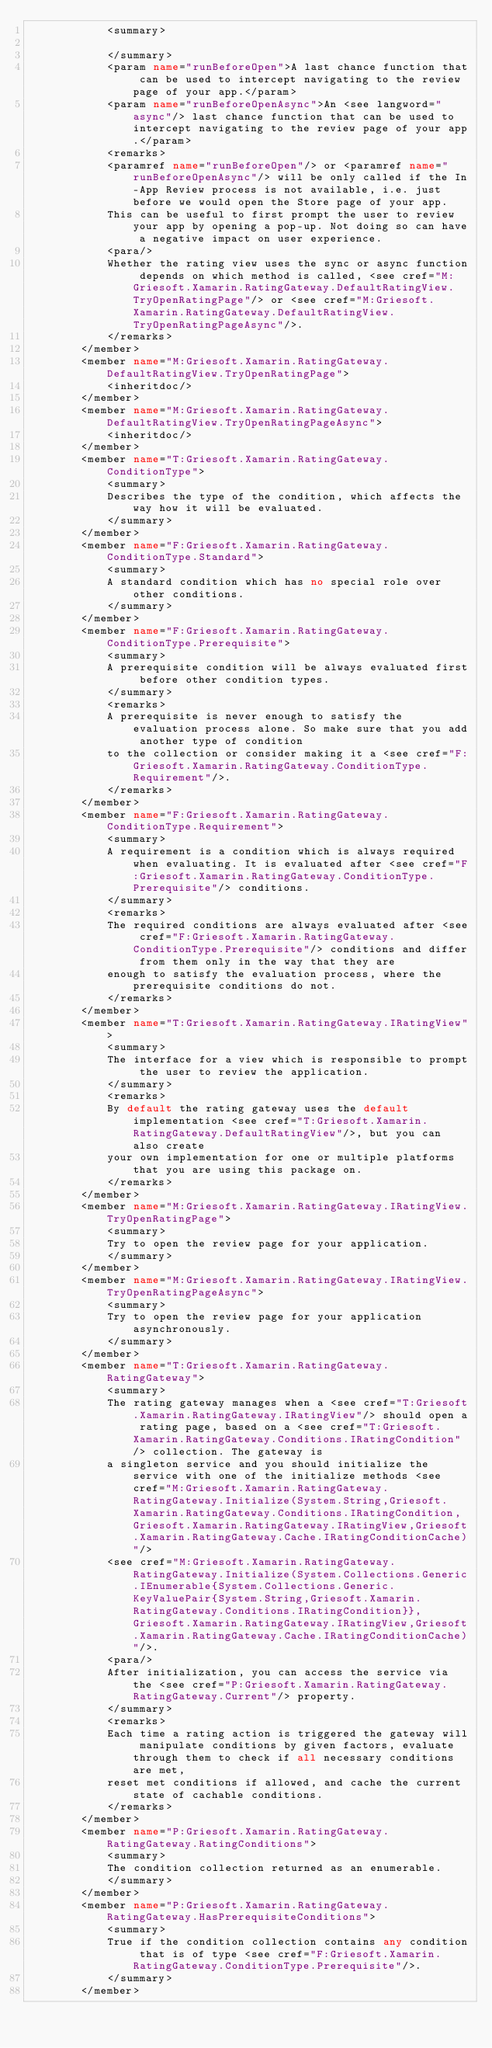<code> <loc_0><loc_0><loc_500><loc_500><_XML_>            <summary>
            
            </summary>
            <param name="runBeforeOpen">A last chance function that can be used to intercept navigating to the review page of your app.</param>
            <param name="runBeforeOpenAsync">An <see langword="async"/> last chance function that can be used to intercept navigating to the review page of your app.</param>
            <remarks>
            <paramref name="runBeforeOpen"/> or <paramref name="runBeforeOpenAsync"/> will be only called if the In-App Review process is not available, i.e. just before we would open the Store page of your app.
            This can be useful to first prompt the user to review your app by opening a pop-up. Not doing so can have a negative impact on user experience.
            <para/>
            Whether the rating view uses the sync or async function depends on which method is called, <see cref="M:Griesoft.Xamarin.RatingGateway.DefaultRatingView.TryOpenRatingPage"/> or <see cref="M:Griesoft.Xamarin.RatingGateway.DefaultRatingView.TryOpenRatingPageAsync"/>.
            </remarks>
        </member>
        <member name="M:Griesoft.Xamarin.RatingGateway.DefaultRatingView.TryOpenRatingPage">
            <inheritdoc/>
        </member>
        <member name="M:Griesoft.Xamarin.RatingGateway.DefaultRatingView.TryOpenRatingPageAsync">
            <inheritdoc/>
        </member>
        <member name="T:Griesoft.Xamarin.RatingGateway.ConditionType">
            <summary>
            Describes the type of the condition, which affects the way how it will be evaluated.
            </summary>
        </member>
        <member name="F:Griesoft.Xamarin.RatingGateway.ConditionType.Standard">
            <summary>
            A standard condition which has no special role over other conditions.
            </summary>
        </member>
        <member name="F:Griesoft.Xamarin.RatingGateway.ConditionType.Prerequisite">
            <summary>
            A prerequisite condition will be always evaluated first before other condition types.
            </summary>
            <remarks>
            A prerequisite is never enough to satisfy the evaluation process alone. So make sure that you add another type of condition
            to the collection or consider making it a <see cref="F:Griesoft.Xamarin.RatingGateway.ConditionType.Requirement"/>.
            </remarks>
        </member>
        <member name="F:Griesoft.Xamarin.RatingGateway.ConditionType.Requirement">
            <summary>
            A requirement is a condition which is always required when evaluating. It is evaluated after <see cref="F:Griesoft.Xamarin.RatingGateway.ConditionType.Prerequisite"/> conditions.
            </summary>
            <remarks>
            The required conditions are always evaluated after <see cref="F:Griesoft.Xamarin.RatingGateway.ConditionType.Prerequisite"/> conditions and differ from them only in the way that they are
            enough to satisfy the evaluation process, where the prerequisite conditions do not.
            </remarks>
        </member>
        <member name="T:Griesoft.Xamarin.RatingGateway.IRatingView">
            <summary>
            The interface for a view which is responsible to prompt the user to review the application.
            </summary>
            <remarks>
            By default the rating gateway uses the default implementation <see cref="T:Griesoft.Xamarin.RatingGateway.DefaultRatingView"/>, but you can also create
            your own implementation for one or multiple platforms that you are using this package on.
            </remarks>
        </member>
        <member name="M:Griesoft.Xamarin.RatingGateway.IRatingView.TryOpenRatingPage">
            <summary>
            Try to open the review page for your application.
            </summary>
        </member>
        <member name="M:Griesoft.Xamarin.RatingGateway.IRatingView.TryOpenRatingPageAsync">
            <summary>
            Try to open the review page for your application asynchronously.
            </summary>
        </member>
        <member name="T:Griesoft.Xamarin.RatingGateway.RatingGateway">
            <summary>
            The rating gateway manages when a <see cref="T:Griesoft.Xamarin.RatingGateway.IRatingView"/> should open a rating page, based on a <see cref="T:Griesoft.Xamarin.RatingGateway.Conditions.IRatingCondition"/> collection. The gateway is
            a singleton service and you should initialize the service with one of the initialize methods <see cref="M:Griesoft.Xamarin.RatingGateway.RatingGateway.Initialize(System.String,Griesoft.Xamarin.RatingGateway.Conditions.IRatingCondition,Griesoft.Xamarin.RatingGateway.IRatingView,Griesoft.Xamarin.RatingGateway.Cache.IRatingConditionCache)"/>
            <see cref="M:Griesoft.Xamarin.RatingGateway.RatingGateway.Initialize(System.Collections.Generic.IEnumerable{System.Collections.Generic.KeyValuePair{System.String,Griesoft.Xamarin.RatingGateway.Conditions.IRatingCondition}},Griesoft.Xamarin.RatingGateway.IRatingView,Griesoft.Xamarin.RatingGateway.Cache.IRatingConditionCache)"/>.
            <para/>
            After initialization, you can access the service via the <see cref="P:Griesoft.Xamarin.RatingGateway.RatingGateway.Current"/> property.
            </summary>
            <remarks>
            Each time a rating action is triggered the gateway will manipulate conditions by given factors, evaluate through them to check if all necessary conditions are met,
            reset met conditions if allowed, and cache the current state of cachable conditions.
            </remarks>
        </member>
        <member name="P:Griesoft.Xamarin.RatingGateway.RatingGateway.RatingConditions">
            <summary>
            The condition collection returned as an enumerable.
            </summary>
        </member>
        <member name="P:Griesoft.Xamarin.RatingGateway.RatingGateway.HasPrerequisiteConditions">
            <summary>
            True if the condition collection contains any condition that is of type <see cref="F:Griesoft.Xamarin.RatingGateway.ConditionType.Prerequisite"/>.
            </summary>
        </member></code> 